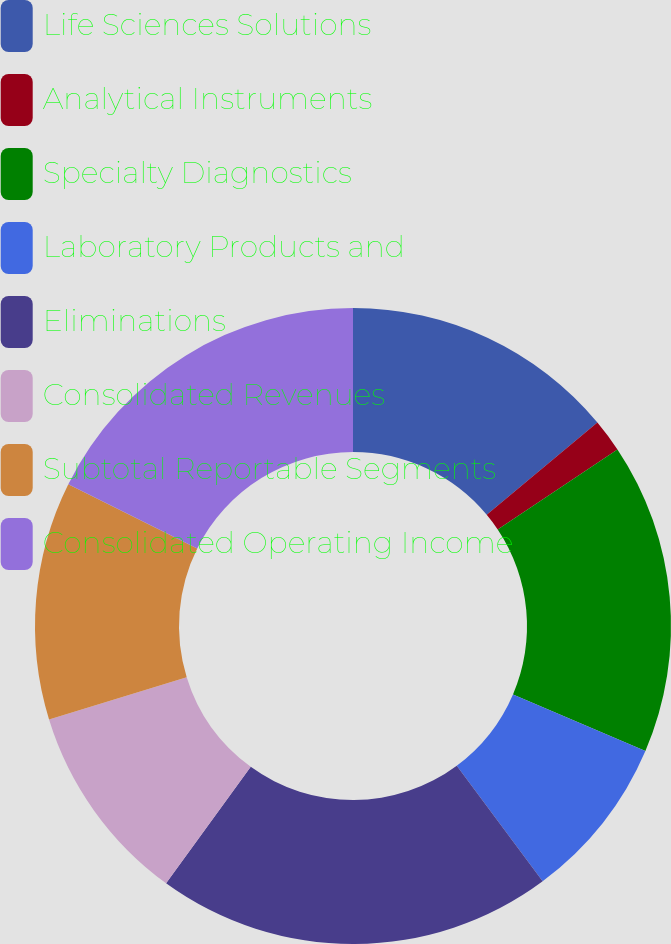<chart> <loc_0><loc_0><loc_500><loc_500><pie_chart><fcel>Life Sciences Solutions<fcel>Analytical Instruments<fcel>Specialty Diagnostics<fcel>Laboratory Products and<fcel>Eliminations<fcel>Consolidated Revenues<fcel>Subtotal Reportable Segments<fcel>Consolidated Operating Income<nl><fcel>13.95%<fcel>1.68%<fcel>15.8%<fcel>8.4%<fcel>20.17%<fcel>10.25%<fcel>12.1%<fcel>17.65%<nl></chart> 